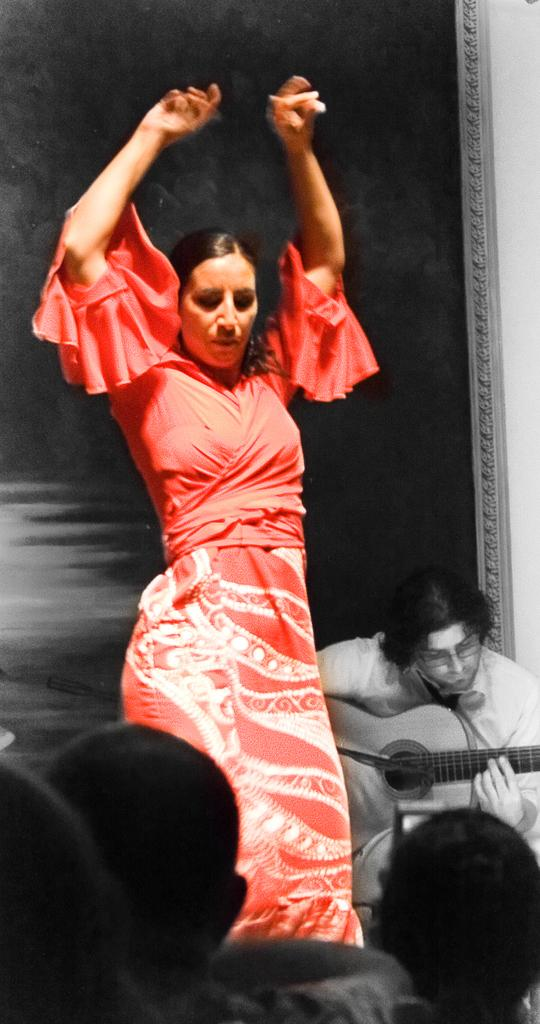Who is the main subject in the image? There is a woman in the image. What is the woman wearing? The woman is wearing a red dress. What is the woman doing in the image? The woman is dancing on a floor. Are there any other people in the image? Yes, there are other persons in front of the woman, and a man is sitting and playing a guitar behind her. What type of pencil can be seen in the woman's hand in the image? There is no pencil visible in the woman's hand or anywhere else in the image. 